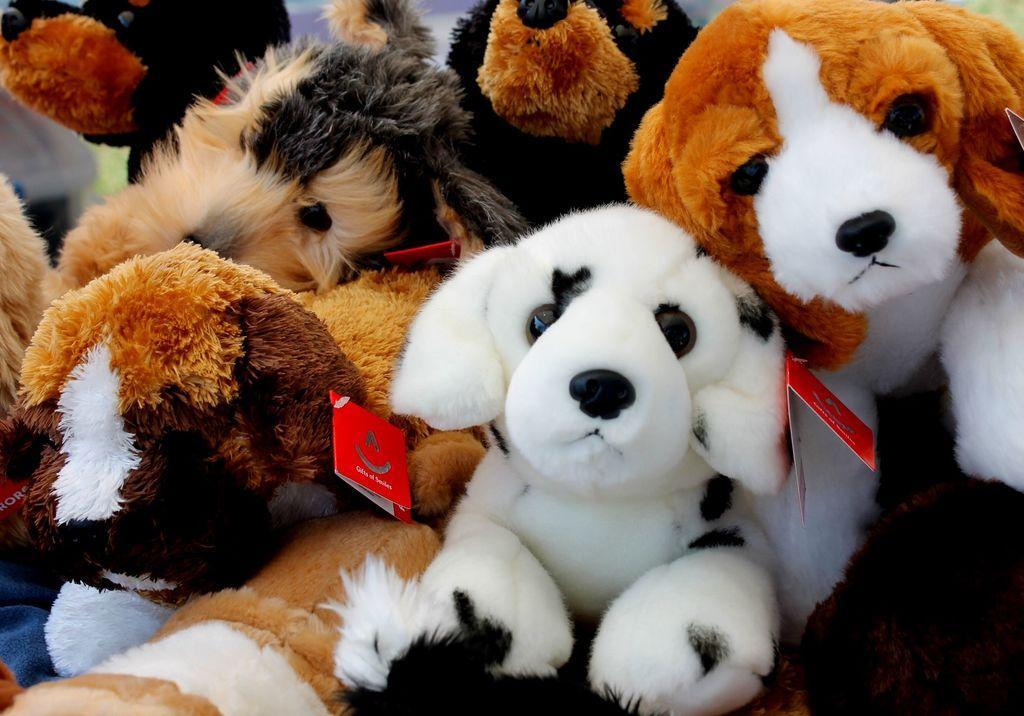Could you give a brief overview of what you see in this image? In this picture I can see toys of dogs with tags to it. 